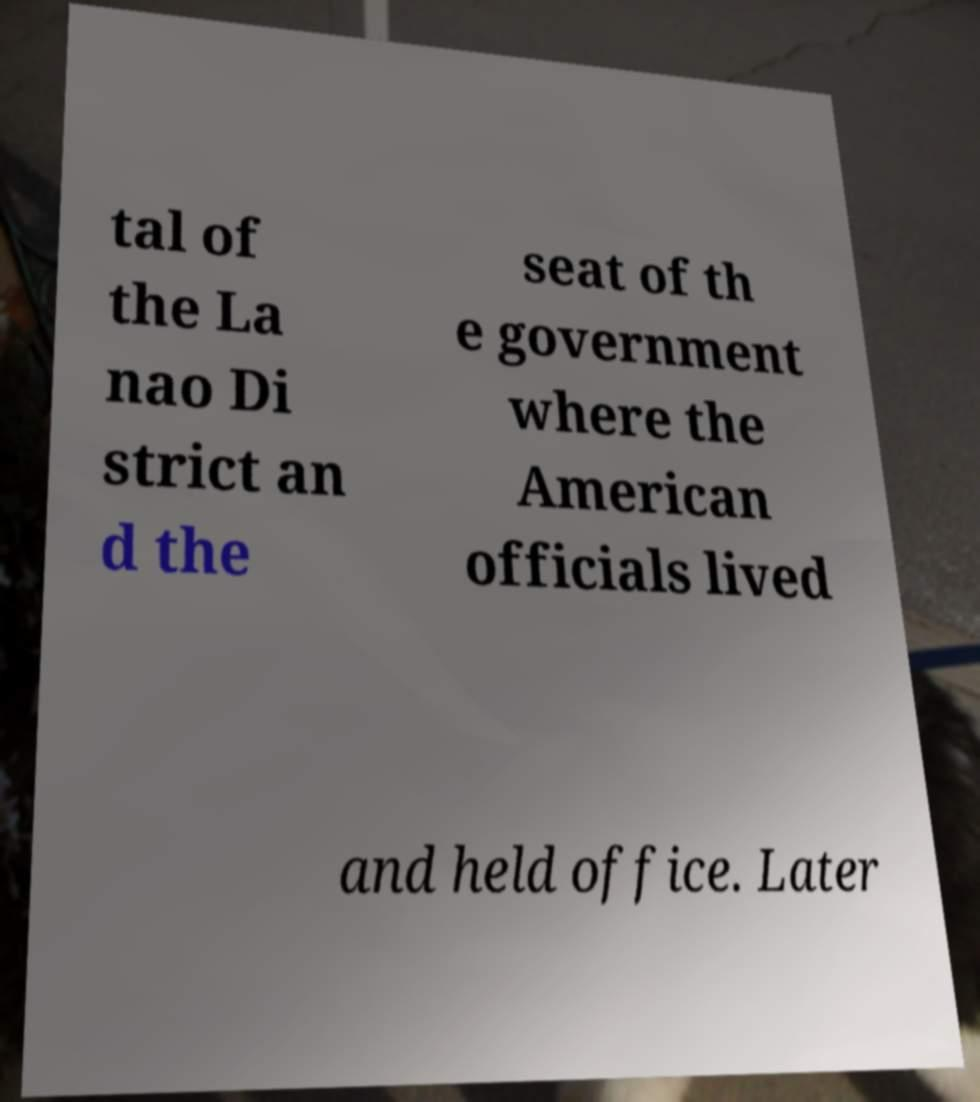For documentation purposes, I need the text within this image transcribed. Could you provide that? tal of the La nao Di strict an d the seat of th e government where the American officials lived and held office. Later 